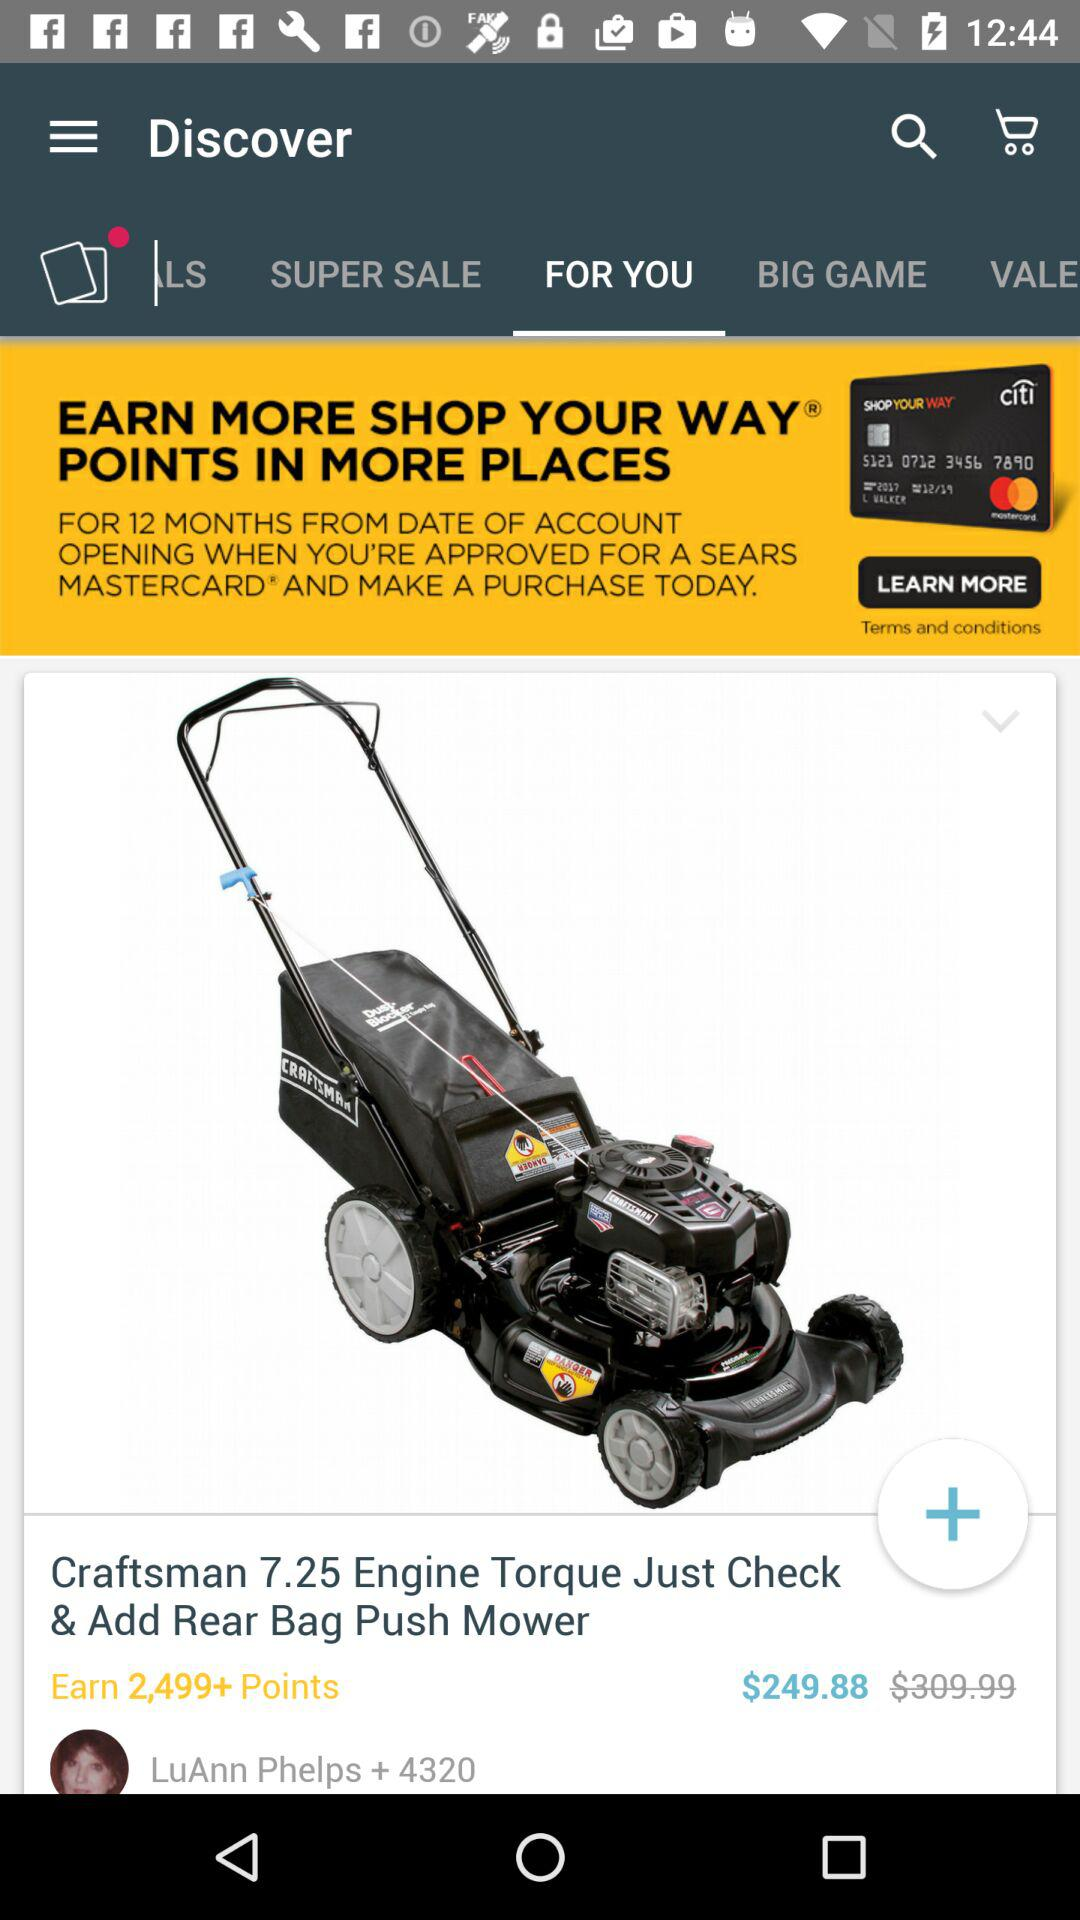How many points can be earned by purchasing the product? The points that can be earnet are more than 2,499. 